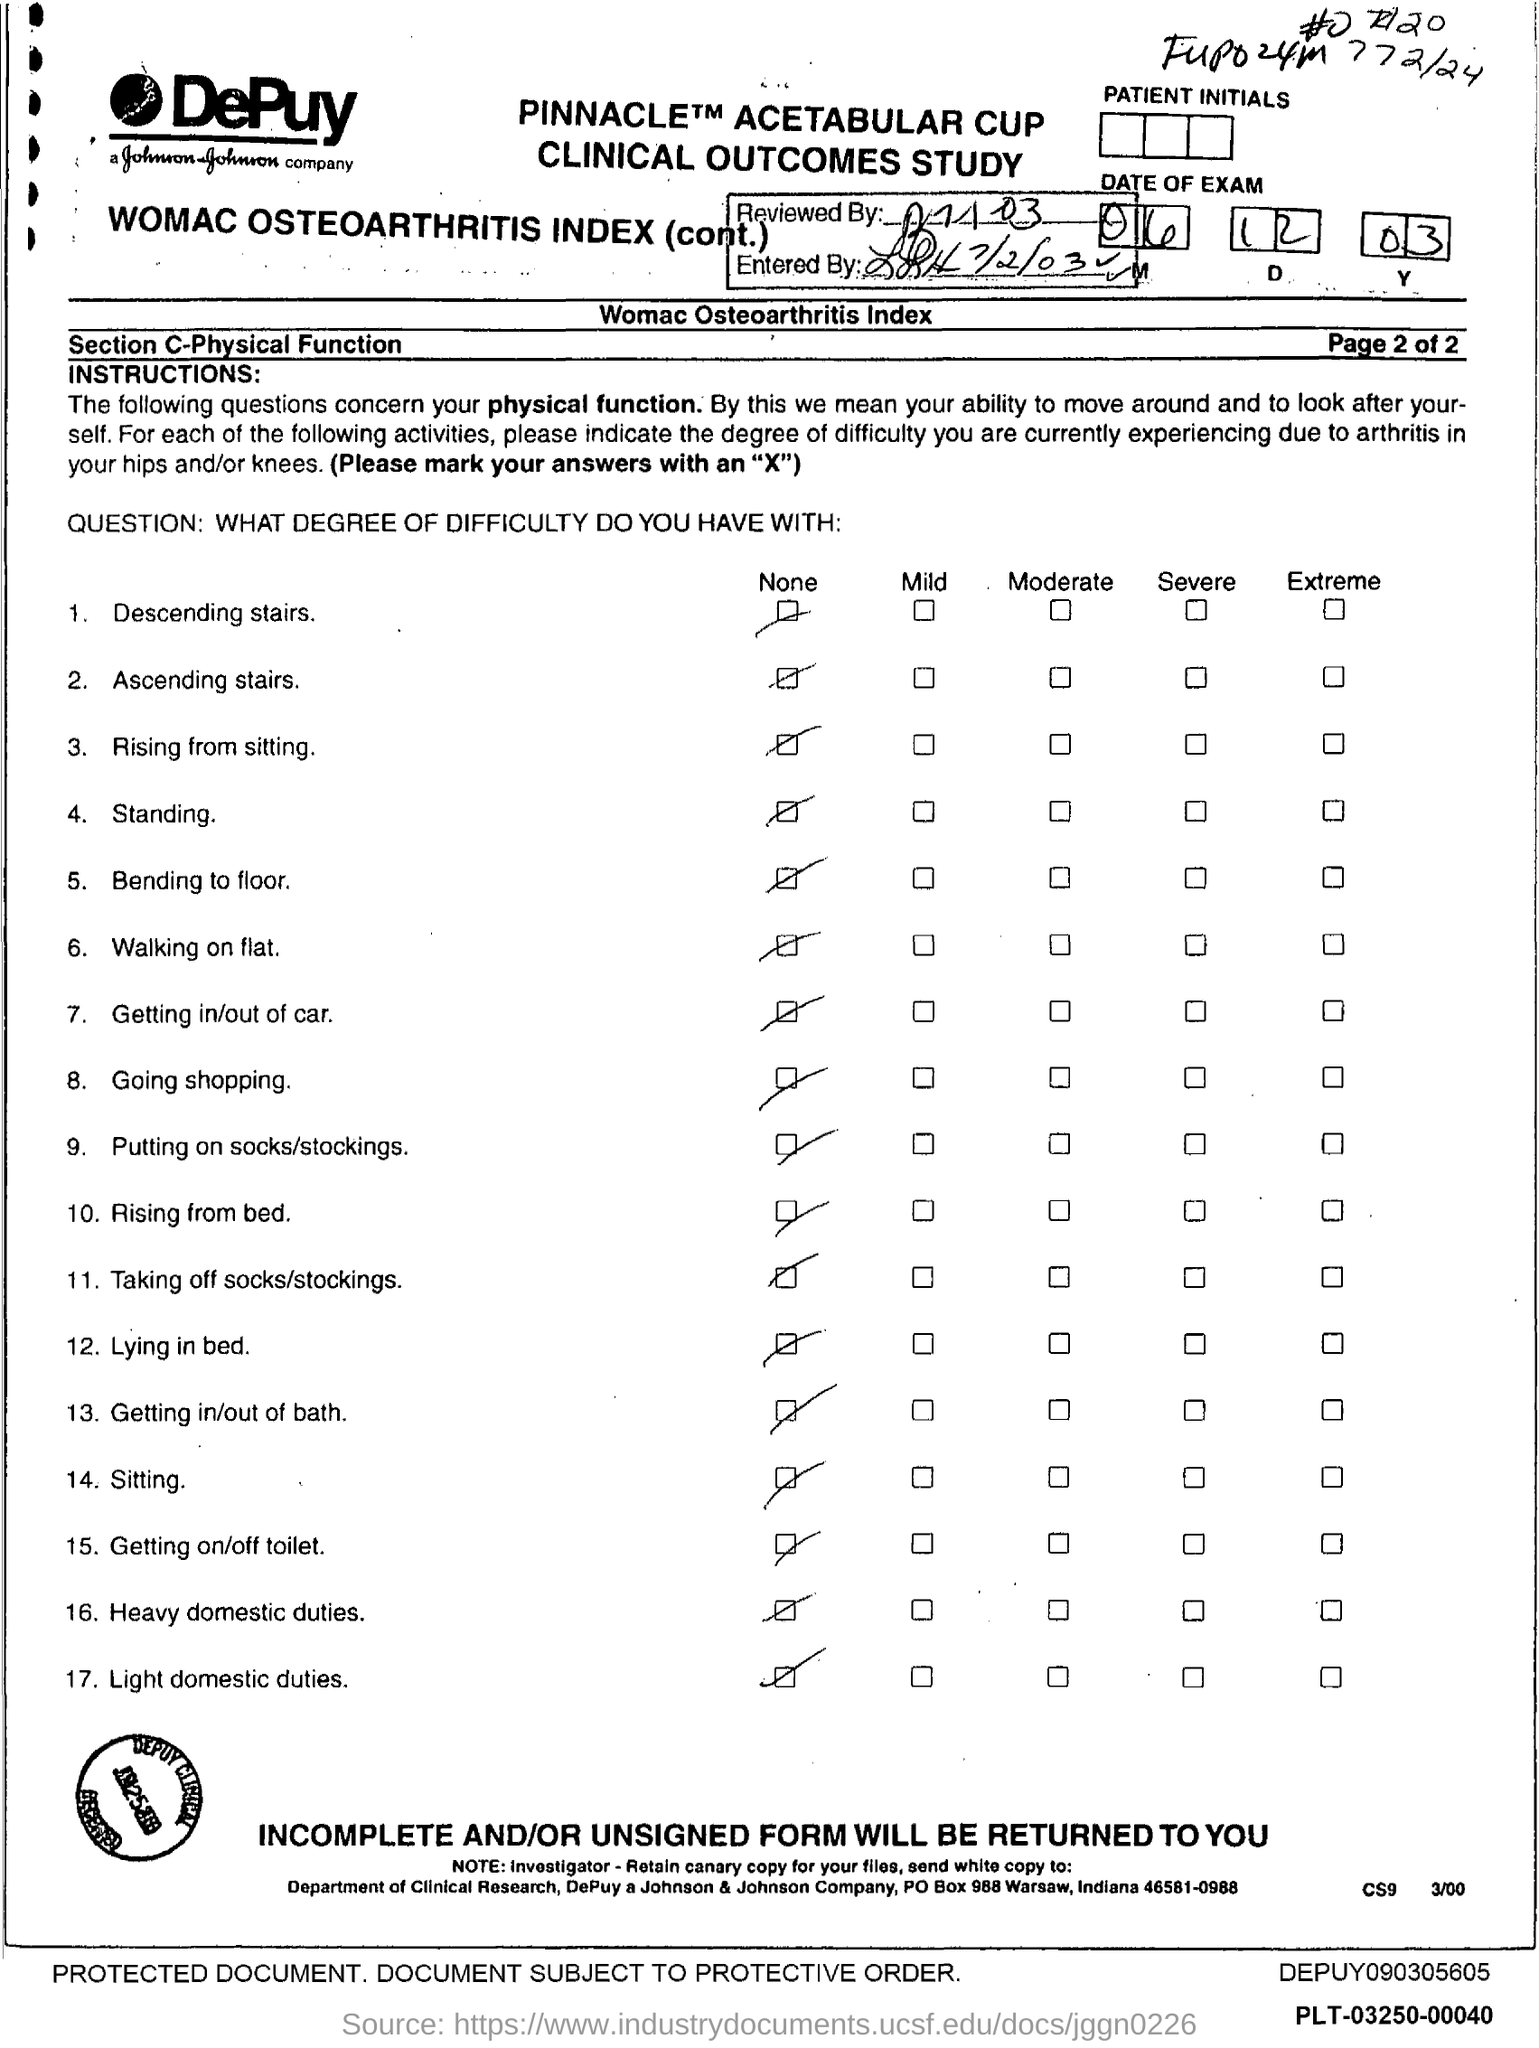Draw attention to some important aspects in this diagram. The document was reviewed on July 1, 2003. 